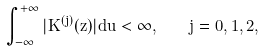Convert formula to latex. <formula><loc_0><loc_0><loc_500><loc_500>\int ^ { + \infty } _ { - \infty } | K ^ { ( j ) } ( z ) | d u < \infty , \quad j = 0 , 1 , 2 ,</formula> 